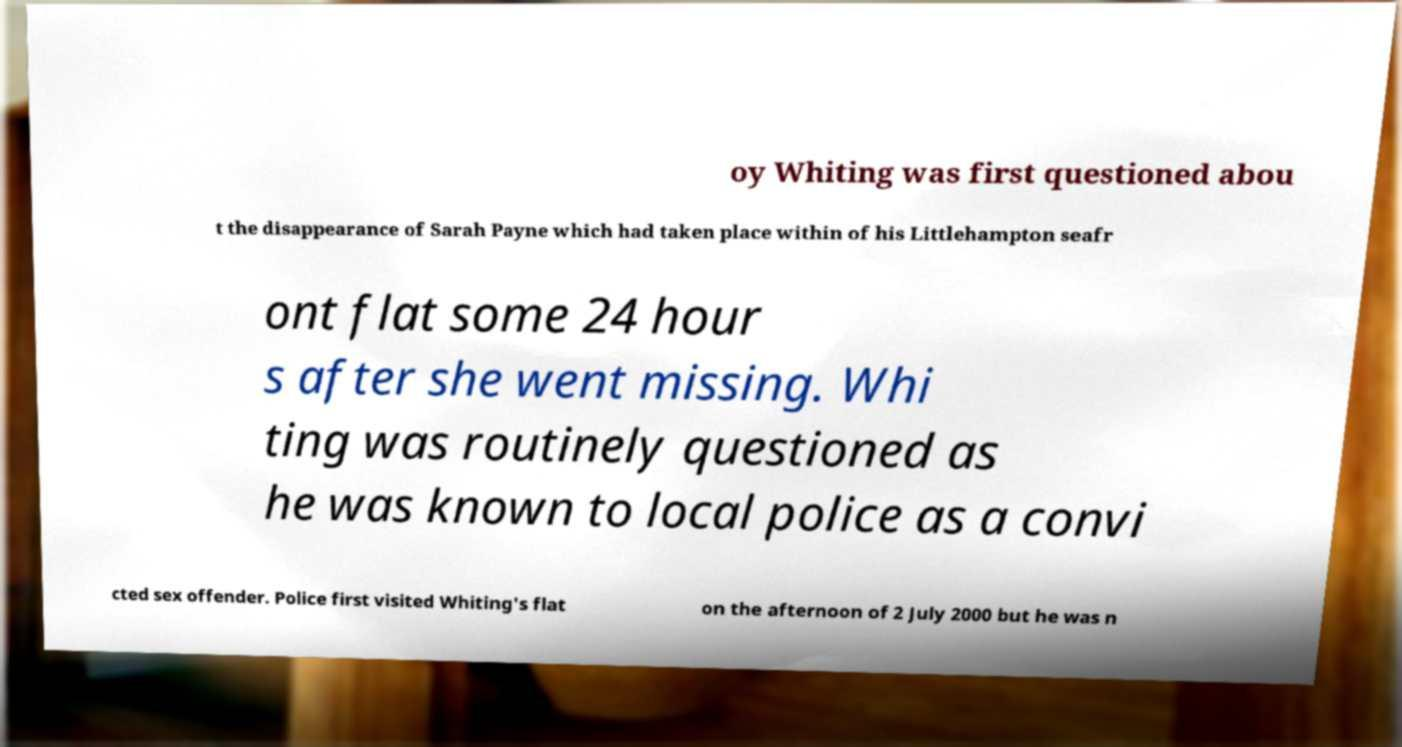What messages or text are displayed in this image? I need them in a readable, typed format. oy Whiting was first questioned abou t the disappearance of Sarah Payne which had taken place within of his Littlehampton seafr ont flat some 24 hour s after she went missing. Whi ting was routinely questioned as he was known to local police as a convi cted sex offender. Police first visited Whiting's flat on the afternoon of 2 July 2000 but he was n 